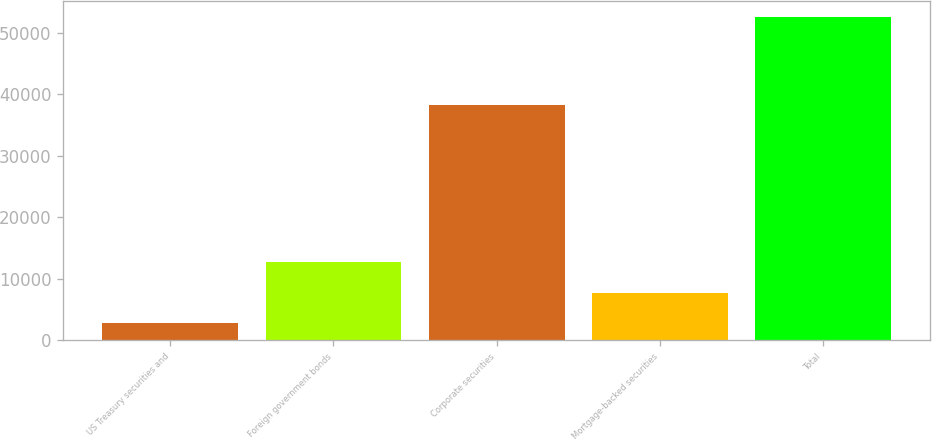<chart> <loc_0><loc_0><loc_500><loc_500><bar_chart><fcel>US Treasury securities and<fcel>Foreign government bonds<fcel>Corporate securities<fcel>Mortgage-backed securities<fcel>Total<nl><fcel>2795<fcel>12734.8<fcel>38273<fcel>7764.9<fcel>52494<nl></chart> 